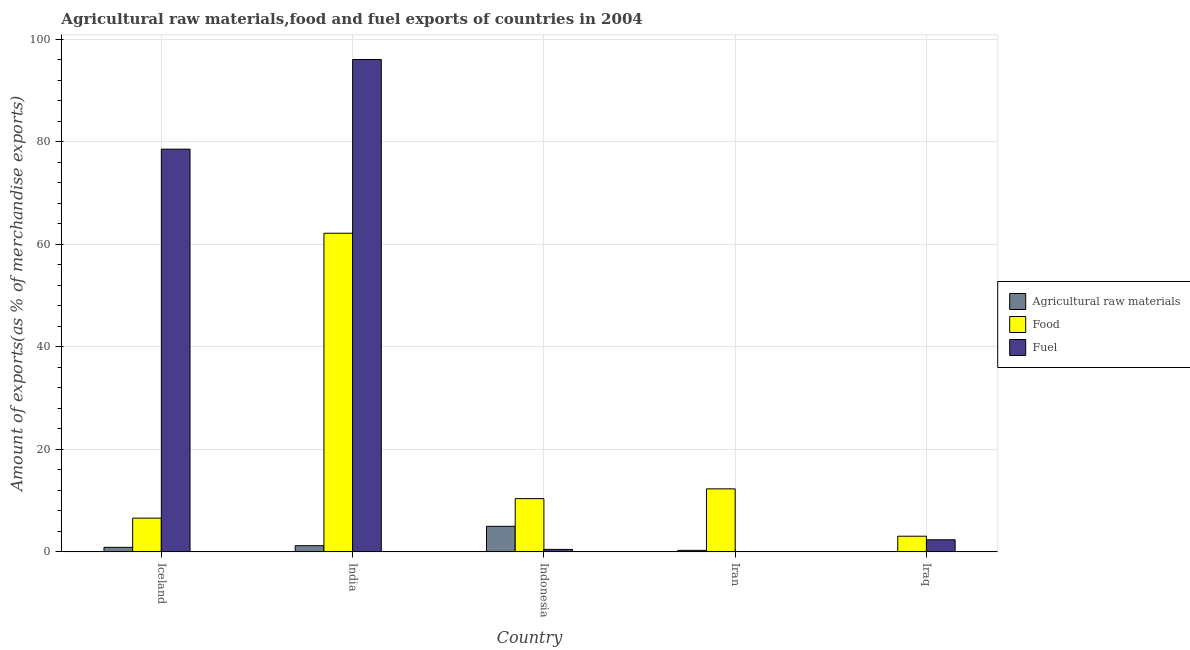How many different coloured bars are there?
Provide a succinct answer. 3. How many bars are there on the 4th tick from the left?
Give a very brief answer. 3. What is the label of the 5th group of bars from the left?
Your answer should be very brief. Iraq. What is the percentage of food exports in India?
Give a very brief answer. 62.14. Across all countries, what is the maximum percentage of raw materials exports?
Your answer should be very brief. 4.98. Across all countries, what is the minimum percentage of food exports?
Your answer should be compact. 3.05. In which country was the percentage of raw materials exports minimum?
Keep it short and to the point. Iraq. What is the total percentage of food exports in the graph?
Make the answer very short. 94.46. What is the difference between the percentage of fuel exports in Iceland and that in Indonesia?
Your response must be concise. 78.06. What is the difference between the percentage of raw materials exports in Iran and the percentage of food exports in Iceland?
Give a very brief answer. -6.28. What is the average percentage of fuel exports per country?
Give a very brief answer. 35.49. What is the difference between the percentage of food exports and percentage of raw materials exports in Indonesia?
Ensure brevity in your answer.  5.4. What is the ratio of the percentage of raw materials exports in Iceland to that in India?
Your answer should be compact. 0.74. Is the percentage of food exports in Iran less than that in Iraq?
Offer a terse response. No. What is the difference between the highest and the second highest percentage of food exports?
Provide a short and direct response. 49.85. What is the difference between the highest and the lowest percentage of food exports?
Make the answer very short. 59.09. Is the sum of the percentage of fuel exports in Iceland and Indonesia greater than the maximum percentage of raw materials exports across all countries?
Give a very brief answer. Yes. What does the 2nd bar from the left in Indonesia represents?
Give a very brief answer. Food. What does the 2nd bar from the right in India represents?
Provide a short and direct response. Food. Is it the case that in every country, the sum of the percentage of raw materials exports and percentage of food exports is greater than the percentage of fuel exports?
Offer a terse response. No. How many bars are there?
Keep it short and to the point. 15. How many countries are there in the graph?
Offer a very short reply. 5. Are the values on the major ticks of Y-axis written in scientific E-notation?
Ensure brevity in your answer.  No. Does the graph contain any zero values?
Ensure brevity in your answer.  No. Does the graph contain grids?
Offer a very short reply. Yes. How many legend labels are there?
Your answer should be compact. 3. How are the legend labels stacked?
Offer a terse response. Vertical. What is the title of the graph?
Provide a short and direct response. Agricultural raw materials,food and fuel exports of countries in 2004. Does "Ages 15-64" appear as one of the legend labels in the graph?
Your response must be concise. No. What is the label or title of the Y-axis?
Give a very brief answer. Amount of exports(as % of merchandise exports). What is the Amount of exports(as % of merchandise exports) of Agricultural raw materials in Iceland?
Make the answer very short. 0.89. What is the Amount of exports(as % of merchandise exports) in Food in Iceland?
Provide a succinct answer. 6.58. What is the Amount of exports(as % of merchandise exports) in Fuel in Iceland?
Make the answer very short. 78.55. What is the Amount of exports(as % of merchandise exports) in Agricultural raw materials in India?
Offer a terse response. 1.2. What is the Amount of exports(as % of merchandise exports) in Food in India?
Give a very brief answer. 62.14. What is the Amount of exports(as % of merchandise exports) in Fuel in India?
Give a very brief answer. 96.03. What is the Amount of exports(as % of merchandise exports) of Agricultural raw materials in Indonesia?
Keep it short and to the point. 4.98. What is the Amount of exports(as % of merchandise exports) of Food in Indonesia?
Keep it short and to the point. 10.39. What is the Amount of exports(as % of merchandise exports) in Fuel in Indonesia?
Your answer should be compact. 0.48. What is the Amount of exports(as % of merchandise exports) of Agricultural raw materials in Iran?
Your answer should be compact. 0.3. What is the Amount of exports(as % of merchandise exports) in Food in Iran?
Provide a succinct answer. 12.29. What is the Amount of exports(as % of merchandise exports) of Fuel in Iran?
Keep it short and to the point. 0.03. What is the Amount of exports(as % of merchandise exports) in Agricultural raw materials in Iraq?
Your answer should be very brief. 0.01. What is the Amount of exports(as % of merchandise exports) in Food in Iraq?
Your response must be concise. 3.05. What is the Amount of exports(as % of merchandise exports) in Fuel in Iraq?
Offer a terse response. 2.36. Across all countries, what is the maximum Amount of exports(as % of merchandise exports) in Agricultural raw materials?
Your answer should be very brief. 4.98. Across all countries, what is the maximum Amount of exports(as % of merchandise exports) in Food?
Offer a very short reply. 62.14. Across all countries, what is the maximum Amount of exports(as % of merchandise exports) of Fuel?
Give a very brief answer. 96.03. Across all countries, what is the minimum Amount of exports(as % of merchandise exports) of Agricultural raw materials?
Ensure brevity in your answer.  0.01. Across all countries, what is the minimum Amount of exports(as % of merchandise exports) of Food?
Offer a terse response. 3.05. Across all countries, what is the minimum Amount of exports(as % of merchandise exports) of Fuel?
Ensure brevity in your answer.  0.03. What is the total Amount of exports(as % of merchandise exports) in Agricultural raw materials in the graph?
Provide a short and direct response. 7.39. What is the total Amount of exports(as % of merchandise exports) of Food in the graph?
Provide a short and direct response. 94.46. What is the total Amount of exports(as % of merchandise exports) of Fuel in the graph?
Provide a succinct answer. 177.44. What is the difference between the Amount of exports(as % of merchandise exports) in Agricultural raw materials in Iceland and that in India?
Give a very brief answer. -0.32. What is the difference between the Amount of exports(as % of merchandise exports) of Food in Iceland and that in India?
Your answer should be very brief. -55.56. What is the difference between the Amount of exports(as % of merchandise exports) of Fuel in Iceland and that in India?
Your answer should be compact. -17.49. What is the difference between the Amount of exports(as % of merchandise exports) of Agricultural raw materials in Iceland and that in Indonesia?
Your response must be concise. -4.1. What is the difference between the Amount of exports(as % of merchandise exports) in Food in Iceland and that in Indonesia?
Your answer should be very brief. -3.81. What is the difference between the Amount of exports(as % of merchandise exports) in Fuel in Iceland and that in Indonesia?
Offer a very short reply. 78.06. What is the difference between the Amount of exports(as % of merchandise exports) in Agricultural raw materials in Iceland and that in Iran?
Keep it short and to the point. 0.59. What is the difference between the Amount of exports(as % of merchandise exports) in Food in Iceland and that in Iran?
Your answer should be compact. -5.71. What is the difference between the Amount of exports(as % of merchandise exports) of Fuel in Iceland and that in Iran?
Your answer should be very brief. 78.52. What is the difference between the Amount of exports(as % of merchandise exports) in Agricultural raw materials in Iceland and that in Iraq?
Give a very brief answer. 0.87. What is the difference between the Amount of exports(as % of merchandise exports) of Food in Iceland and that in Iraq?
Your answer should be compact. 3.53. What is the difference between the Amount of exports(as % of merchandise exports) in Fuel in Iceland and that in Iraq?
Your answer should be very brief. 76.19. What is the difference between the Amount of exports(as % of merchandise exports) of Agricultural raw materials in India and that in Indonesia?
Your response must be concise. -3.78. What is the difference between the Amount of exports(as % of merchandise exports) of Food in India and that in Indonesia?
Provide a short and direct response. 51.76. What is the difference between the Amount of exports(as % of merchandise exports) of Fuel in India and that in Indonesia?
Ensure brevity in your answer.  95.55. What is the difference between the Amount of exports(as % of merchandise exports) in Agricultural raw materials in India and that in Iran?
Ensure brevity in your answer.  0.9. What is the difference between the Amount of exports(as % of merchandise exports) of Food in India and that in Iran?
Provide a short and direct response. 49.85. What is the difference between the Amount of exports(as % of merchandise exports) of Fuel in India and that in Iran?
Offer a terse response. 96. What is the difference between the Amount of exports(as % of merchandise exports) in Agricultural raw materials in India and that in Iraq?
Provide a short and direct response. 1.19. What is the difference between the Amount of exports(as % of merchandise exports) of Food in India and that in Iraq?
Your answer should be compact. 59.09. What is the difference between the Amount of exports(as % of merchandise exports) of Fuel in India and that in Iraq?
Provide a succinct answer. 93.68. What is the difference between the Amount of exports(as % of merchandise exports) in Agricultural raw materials in Indonesia and that in Iran?
Your answer should be very brief. 4.68. What is the difference between the Amount of exports(as % of merchandise exports) in Food in Indonesia and that in Iran?
Provide a succinct answer. -1.9. What is the difference between the Amount of exports(as % of merchandise exports) in Fuel in Indonesia and that in Iran?
Offer a terse response. 0.45. What is the difference between the Amount of exports(as % of merchandise exports) of Agricultural raw materials in Indonesia and that in Iraq?
Your answer should be compact. 4.97. What is the difference between the Amount of exports(as % of merchandise exports) of Food in Indonesia and that in Iraq?
Give a very brief answer. 7.33. What is the difference between the Amount of exports(as % of merchandise exports) in Fuel in Indonesia and that in Iraq?
Give a very brief answer. -1.87. What is the difference between the Amount of exports(as % of merchandise exports) in Agricultural raw materials in Iran and that in Iraq?
Give a very brief answer. 0.29. What is the difference between the Amount of exports(as % of merchandise exports) in Food in Iran and that in Iraq?
Give a very brief answer. 9.24. What is the difference between the Amount of exports(as % of merchandise exports) in Fuel in Iran and that in Iraq?
Keep it short and to the point. -2.33. What is the difference between the Amount of exports(as % of merchandise exports) in Agricultural raw materials in Iceland and the Amount of exports(as % of merchandise exports) in Food in India?
Your answer should be very brief. -61.26. What is the difference between the Amount of exports(as % of merchandise exports) of Agricultural raw materials in Iceland and the Amount of exports(as % of merchandise exports) of Fuel in India?
Provide a short and direct response. -95.15. What is the difference between the Amount of exports(as % of merchandise exports) in Food in Iceland and the Amount of exports(as % of merchandise exports) in Fuel in India?
Offer a terse response. -89.45. What is the difference between the Amount of exports(as % of merchandise exports) of Agricultural raw materials in Iceland and the Amount of exports(as % of merchandise exports) of Food in Indonesia?
Your response must be concise. -9.5. What is the difference between the Amount of exports(as % of merchandise exports) of Agricultural raw materials in Iceland and the Amount of exports(as % of merchandise exports) of Fuel in Indonesia?
Offer a terse response. 0.4. What is the difference between the Amount of exports(as % of merchandise exports) in Food in Iceland and the Amount of exports(as % of merchandise exports) in Fuel in Indonesia?
Ensure brevity in your answer.  6.1. What is the difference between the Amount of exports(as % of merchandise exports) in Agricultural raw materials in Iceland and the Amount of exports(as % of merchandise exports) in Food in Iran?
Make the answer very short. -11.41. What is the difference between the Amount of exports(as % of merchandise exports) of Agricultural raw materials in Iceland and the Amount of exports(as % of merchandise exports) of Fuel in Iran?
Provide a succinct answer. 0.86. What is the difference between the Amount of exports(as % of merchandise exports) in Food in Iceland and the Amount of exports(as % of merchandise exports) in Fuel in Iran?
Keep it short and to the point. 6.56. What is the difference between the Amount of exports(as % of merchandise exports) in Agricultural raw materials in Iceland and the Amount of exports(as % of merchandise exports) in Food in Iraq?
Provide a succinct answer. -2.17. What is the difference between the Amount of exports(as % of merchandise exports) in Agricultural raw materials in Iceland and the Amount of exports(as % of merchandise exports) in Fuel in Iraq?
Offer a terse response. -1.47. What is the difference between the Amount of exports(as % of merchandise exports) of Food in Iceland and the Amount of exports(as % of merchandise exports) of Fuel in Iraq?
Make the answer very short. 4.23. What is the difference between the Amount of exports(as % of merchandise exports) in Agricultural raw materials in India and the Amount of exports(as % of merchandise exports) in Food in Indonesia?
Your answer should be very brief. -9.18. What is the difference between the Amount of exports(as % of merchandise exports) of Agricultural raw materials in India and the Amount of exports(as % of merchandise exports) of Fuel in Indonesia?
Keep it short and to the point. 0.72. What is the difference between the Amount of exports(as % of merchandise exports) in Food in India and the Amount of exports(as % of merchandise exports) in Fuel in Indonesia?
Keep it short and to the point. 61.66. What is the difference between the Amount of exports(as % of merchandise exports) in Agricultural raw materials in India and the Amount of exports(as % of merchandise exports) in Food in Iran?
Make the answer very short. -11.09. What is the difference between the Amount of exports(as % of merchandise exports) in Agricultural raw materials in India and the Amount of exports(as % of merchandise exports) in Fuel in Iran?
Your answer should be very brief. 1.18. What is the difference between the Amount of exports(as % of merchandise exports) of Food in India and the Amount of exports(as % of merchandise exports) of Fuel in Iran?
Your answer should be very brief. 62.12. What is the difference between the Amount of exports(as % of merchandise exports) of Agricultural raw materials in India and the Amount of exports(as % of merchandise exports) of Food in Iraq?
Make the answer very short. -1.85. What is the difference between the Amount of exports(as % of merchandise exports) in Agricultural raw materials in India and the Amount of exports(as % of merchandise exports) in Fuel in Iraq?
Your response must be concise. -1.15. What is the difference between the Amount of exports(as % of merchandise exports) in Food in India and the Amount of exports(as % of merchandise exports) in Fuel in Iraq?
Your answer should be very brief. 59.79. What is the difference between the Amount of exports(as % of merchandise exports) of Agricultural raw materials in Indonesia and the Amount of exports(as % of merchandise exports) of Food in Iran?
Your answer should be compact. -7.31. What is the difference between the Amount of exports(as % of merchandise exports) in Agricultural raw materials in Indonesia and the Amount of exports(as % of merchandise exports) in Fuel in Iran?
Give a very brief answer. 4.96. What is the difference between the Amount of exports(as % of merchandise exports) in Food in Indonesia and the Amount of exports(as % of merchandise exports) in Fuel in Iran?
Ensure brevity in your answer.  10.36. What is the difference between the Amount of exports(as % of merchandise exports) of Agricultural raw materials in Indonesia and the Amount of exports(as % of merchandise exports) of Food in Iraq?
Your answer should be compact. 1.93. What is the difference between the Amount of exports(as % of merchandise exports) of Agricultural raw materials in Indonesia and the Amount of exports(as % of merchandise exports) of Fuel in Iraq?
Keep it short and to the point. 2.63. What is the difference between the Amount of exports(as % of merchandise exports) in Food in Indonesia and the Amount of exports(as % of merchandise exports) in Fuel in Iraq?
Keep it short and to the point. 8.03. What is the difference between the Amount of exports(as % of merchandise exports) in Agricultural raw materials in Iran and the Amount of exports(as % of merchandise exports) in Food in Iraq?
Your answer should be very brief. -2.75. What is the difference between the Amount of exports(as % of merchandise exports) of Agricultural raw materials in Iran and the Amount of exports(as % of merchandise exports) of Fuel in Iraq?
Your response must be concise. -2.06. What is the difference between the Amount of exports(as % of merchandise exports) of Food in Iran and the Amount of exports(as % of merchandise exports) of Fuel in Iraq?
Your answer should be compact. 9.94. What is the average Amount of exports(as % of merchandise exports) in Agricultural raw materials per country?
Offer a very short reply. 1.48. What is the average Amount of exports(as % of merchandise exports) of Food per country?
Your answer should be very brief. 18.89. What is the average Amount of exports(as % of merchandise exports) in Fuel per country?
Your answer should be compact. 35.49. What is the difference between the Amount of exports(as % of merchandise exports) of Agricultural raw materials and Amount of exports(as % of merchandise exports) of Food in Iceland?
Provide a short and direct response. -5.7. What is the difference between the Amount of exports(as % of merchandise exports) in Agricultural raw materials and Amount of exports(as % of merchandise exports) in Fuel in Iceland?
Your answer should be very brief. -77.66. What is the difference between the Amount of exports(as % of merchandise exports) of Food and Amount of exports(as % of merchandise exports) of Fuel in Iceland?
Provide a succinct answer. -71.96. What is the difference between the Amount of exports(as % of merchandise exports) of Agricultural raw materials and Amount of exports(as % of merchandise exports) of Food in India?
Offer a terse response. -60.94. What is the difference between the Amount of exports(as % of merchandise exports) in Agricultural raw materials and Amount of exports(as % of merchandise exports) in Fuel in India?
Offer a very short reply. -94.83. What is the difference between the Amount of exports(as % of merchandise exports) of Food and Amount of exports(as % of merchandise exports) of Fuel in India?
Keep it short and to the point. -33.89. What is the difference between the Amount of exports(as % of merchandise exports) in Agricultural raw materials and Amount of exports(as % of merchandise exports) in Food in Indonesia?
Provide a short and direct response. -5.4. What is the difference between the Amount of exports(as % of merchandise exports) of Agricultural raw materials and Amount of exports(as % of merchandise exports) of Fuel in Indonesia?
Offer a very short reply. 4.5. What is the difference between the Amount of exports(as % of merchandise exports) in Food and Amount of exports(as % of merchandise exports) in Fuel in Indonesia?
Offer a very short reply. 9.91. What is the difference between the Amount of exports(as % of merchandise exports) in Agricultural raw materials and Amount of exports(as % of merchandise exports) in Food in Iran?
Offer a terse response. -11.99. What is the difference between the Amount of exports(as % of merchandise exports) in Agricultural raw materials and Amount of exports(as % of merchandise exports) in Fuel in Iran?
Ensure brevity in your answer.  0.27. What is the difference between the Amount of exports(as % of merchandise exports) in Food and Amount of exports(as % of merchandise exports) in Fuel in Iran?
Your answer should be very brief. 12.26. What is the difference between the Amount of exports(as % of merchandise exports) in Agricultural raw materials and Amount of exports(as % of merchandise exports) in Food in Iraq?
Your response must be concise. -3.04. What is the difference between the Amount of exports(as % of merchandise exports) in Agricultural raw materials and Amount of exports(as % of merchandise exports) in Fuel in Iraq?
Ensure brevity in your answer.  -2.34. What is the difference between the Amount of exports(as % of merchandise exports) in Food and Amount of exports(as % of merchandise exports) in Fuel in Iraq?
Your response must be concise. 0.7. What is the ratio of the Amount of exports(as % of merchandise exports) in Agricultural raw materials in Iceland to that in India?
Provide a short and direct response. 0.74. What is the ratio of the Amount of exports(as % of merchandise exports) of Food in Iceland to that in India?
Make the answer very short. 0.11. What is the ratio of the Amount of exports(as % of merchandise exports) in Fuel in Iceland to that in India?
Your answer should be very brief. 0.82. What is the ratio of the Amount of exports(as % of merchandise exports) in Agricultural raw materials in Iceland to that in Indonesia?
Your answer should be compact. 0.18. What is the ratio of the Amount of exports(as % of merchandise exports) of Food in Iceland to that in Indonesia?
Provide a succinct answer. 0.63. What is the ratio of the Amount of exports(as % of merchandise exports) in Fuel in Iceland to that in Indonesia?
Make the answer very short. 162.92. What is the ratio of the Amount of exports(as % of merchandise exports) in Agricultural raw materials in Iceland to that in Iran?
Provide a succinct answer. 2.95. What is the ratio of the Amount of exports(as % of merchandise exports) in Food in Iceland to that in Iran?
Ensure brevity in your answer.  0.54. What is the ratio of the Amount of exports(as % of merchandise exports) of Fuel in Iceland to that in Iran?
Make the answer very short. 2867.1. What is the ratio of the Amount of exports(as % of merchandise exports) in Agricultural raw materials in Iceland to that in Iraq?
Provide a short and direct response. 59.72. What is the ratio of the Amount of exports(as % of merchandise exports) of Food in Iceland to that in Iraq?
Offer a very short reply. 2.16. What is the ratio of the Amount of exports(as % of merchandise exports) in Fuel in Iceland to that in Iraq?
Offer a terse response. 33.34. What is the ratio of the Amount of exports(as % of merchandise exports) of Agricultural raw materials in India to that in Indonesia?
Offer a terse response. 0.24. What is the ratio of the Amount of exports(as % of merchandise exports) of Food in India to that in Indonesia?
Your response must be concise. 5.98. What is the ratio of the Amount of exports(as % of merchandise exports) in Fuel in India to that in Indonesia?
Keep it short and to the point. 199.19. What is the ratio of the Amount of exports(as % of merchandise exports) in Agricultural raw materials in India to that in Iran?
Your answer should be compact. 4.01. What is the ratio of the Amount of exports(as % of merchandise exports) in Food in India to that in Iran?
Your answer should be very brief. 5.06. What is the ratio of the Amount of exports(as % of merchandise exports) in Fuel in India to that in Iran?
Provide a succinct answer. 3505.35. What is the ratio of the Amount of exports(as % of merchandise exports) of Agricultural raw materials in India to that in Iraq?
Offer a very short reply. 81.1. What is the ratio of the Amount of exports(as % of merchandise exports) in Food in India to that in Iraq?
Give a very brief answer. 20.35. What is the ratio of the Amount of exports(as % of merchandise exports) in Fuel in India to that in Iraq?
Give a very brief answer. 40.76. What is the ratio of the Amount of exports(as % of merchandise exports) of Agricultural raw materials in Indonesia to that in Iran?
Provide a succinct answer. 16.6. What is the ratio of the Amount of exports(as % of merchandise exports) in Food in Indonesia to that in Iran?
Provide a short and direct response. 0.85. What is the ratio of the Amount of exports(as % of merchandise exports) of Fuel in Indonesia to that in Iran?
Offer a very short reply. 17.6. What is the ratio of the Amount of exports(as % of merchandise exports) of Agricultural raw materials in Indonesia to that in Iraq?
Offer a terse response. 335.75. What is the ratio of the Amount of exports(as % of merchandise exports) of Food in Indonesia to that in Iraq?
Keep it short and to the point. 3.4. What is the ratio of the Amount of exports(as % of merchandise exports) of Fuel in Indonesia to that in Iraq?
Give a very brief answer. 0.2. What is the ratio of the Amount of exports(as % of merchandise exports) in Agricultural raw materials in Iran to that in Iraq?
Provide a short and direct response. 20.23. What is the ratio of the Amount of exports(as % of merchandise exports) in Food in Iran to that in Iraq?
Your answer should be very brief. 4.03. What is the ratio of the Amount of exports(as % of merchandise exports) of Fuel in Iran to that in Iraq?
Keep it short and to the point. 0.01. What is the difference between the highest and the second highest Amount of exports(as % of merchandise exports) of Agricultural raw materials?
Your response must be concise. 3.78. What is the difference between the highest and the second highest Amount of exports(as % of merchandise exports) of Food?
Ensure brevity in your answer.  49.85. What is the difference between the highest and the second highest Amount of exports(as % of merchandise exports) of Fuel?
Offer a terse response. 17.49. What is the difference between the highest and the lowest Amount of exports(as % of merchandise exports) in Agricultural raw materials?
Your answer should be very brief. 4.97. What is the difference between the highest and the lowest Amount of exports(as % of merchandise exports) of Food?
Your answer should be very brief. 59.09. What is the difference between the highest and the lowest Amount of exports(as % of merchandise exports) in Fuel?
Your response must be concise. 96. 